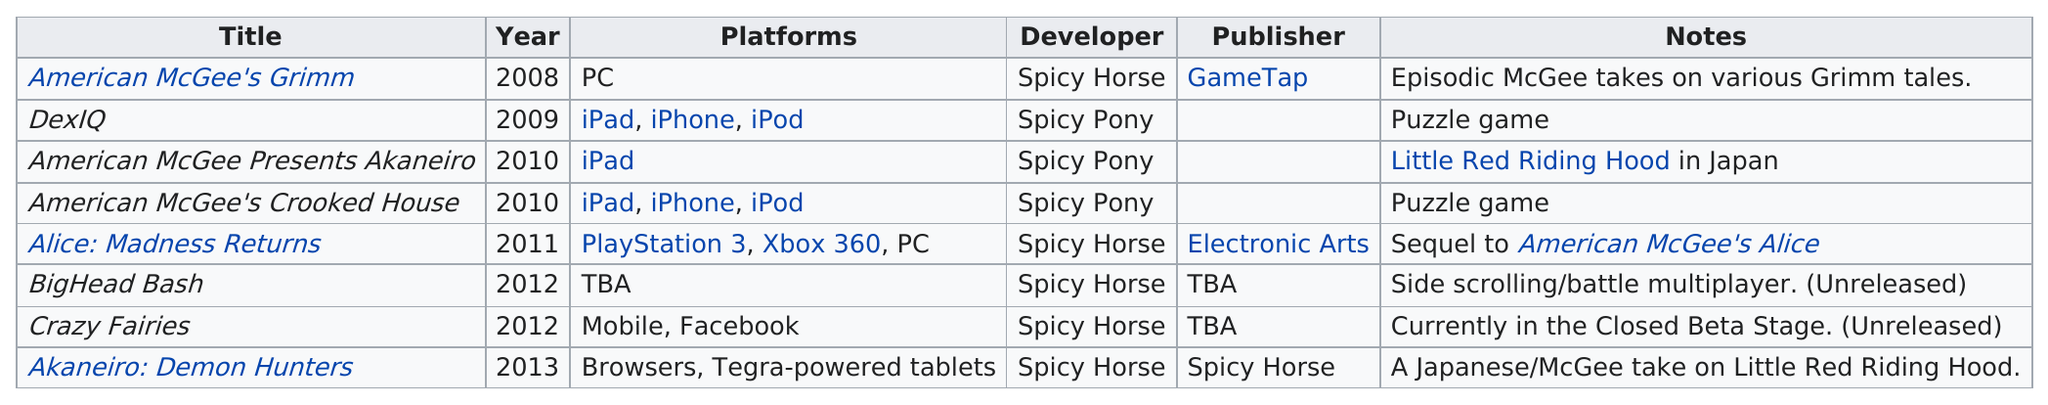Draw attention to some important aspects in this diagram. The total number of times Spicy Pony is listed as the developer is 3. The title 'American McGee Presents Akaneiro' is intended for use on an iPad, but it is not suitable for an iPhone or iPod. Spicy Horse has developed a total of five games. American McGee's Grimm ran on one platform. Spicy Pony, a game development company, released a total of three games, including "American McGee's Crooked House," which was released on the platforms of iPad, iPhone, and iPod. 